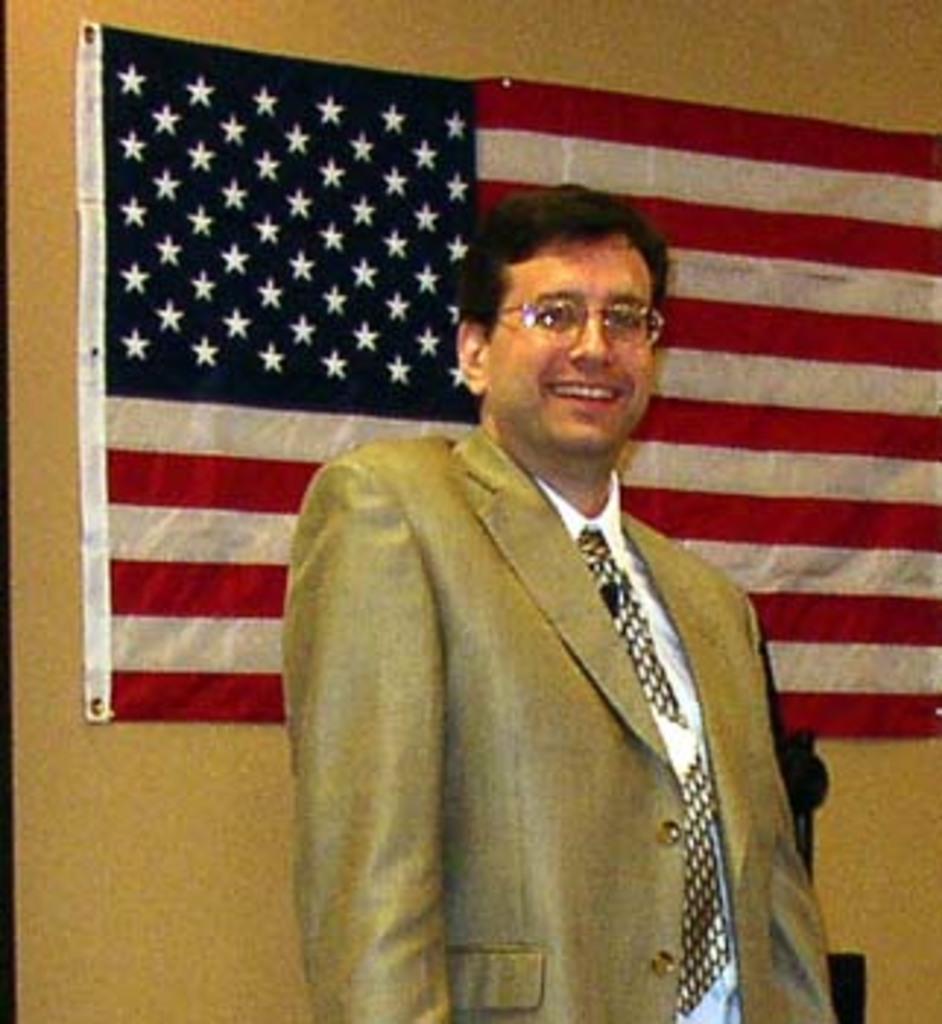Describe this image in one or two sentences. In this image I can see the person standing and the person is wearing cream color blazer, white color shirt. In the background I can see the flag attached to the wall and the flag is in red, white and blue color and the wall is in brown color. 